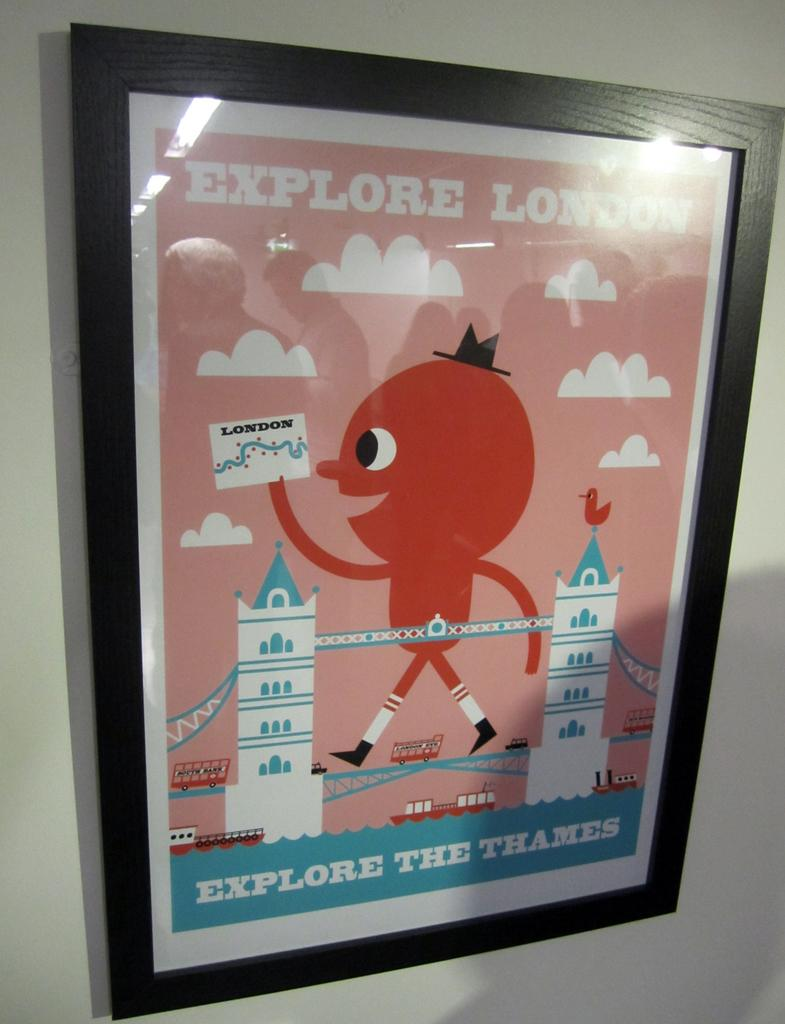Provide a one-sentence caption for the provided image. A red and blue sign with Explore London on it. 